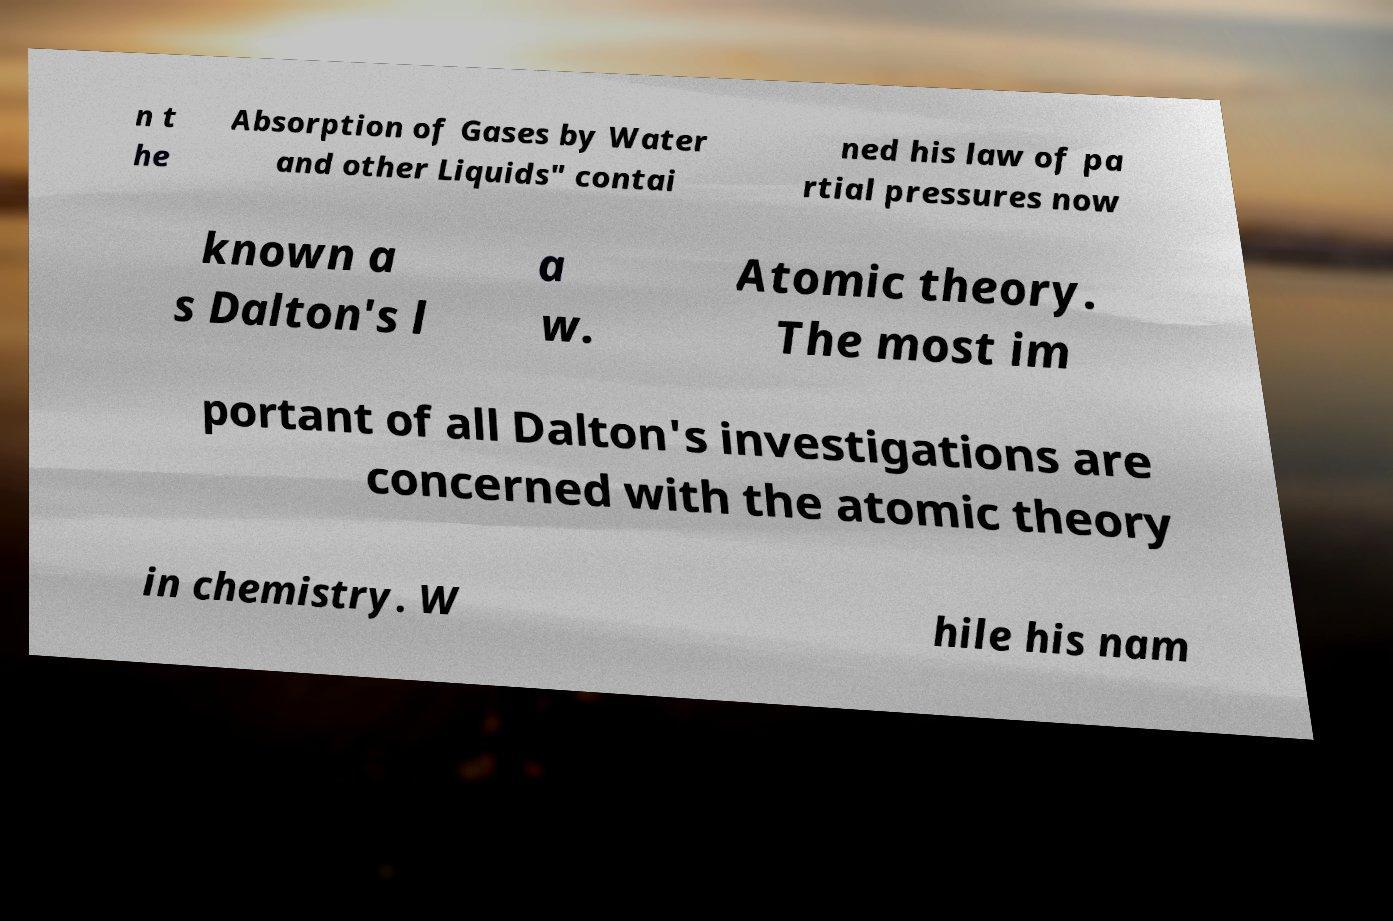There's text embedded in this image that I need extracted. Can you transcribe it verbatim? n t he Absorption of Gases by Water and other Liquids" contai ned his law of pa rtial pressures now known a s Dalton's l a w. Atomic theory. The most im portant of all Dalton's investigations are concerned with the atomic theory in chemistry. W hile his nam 